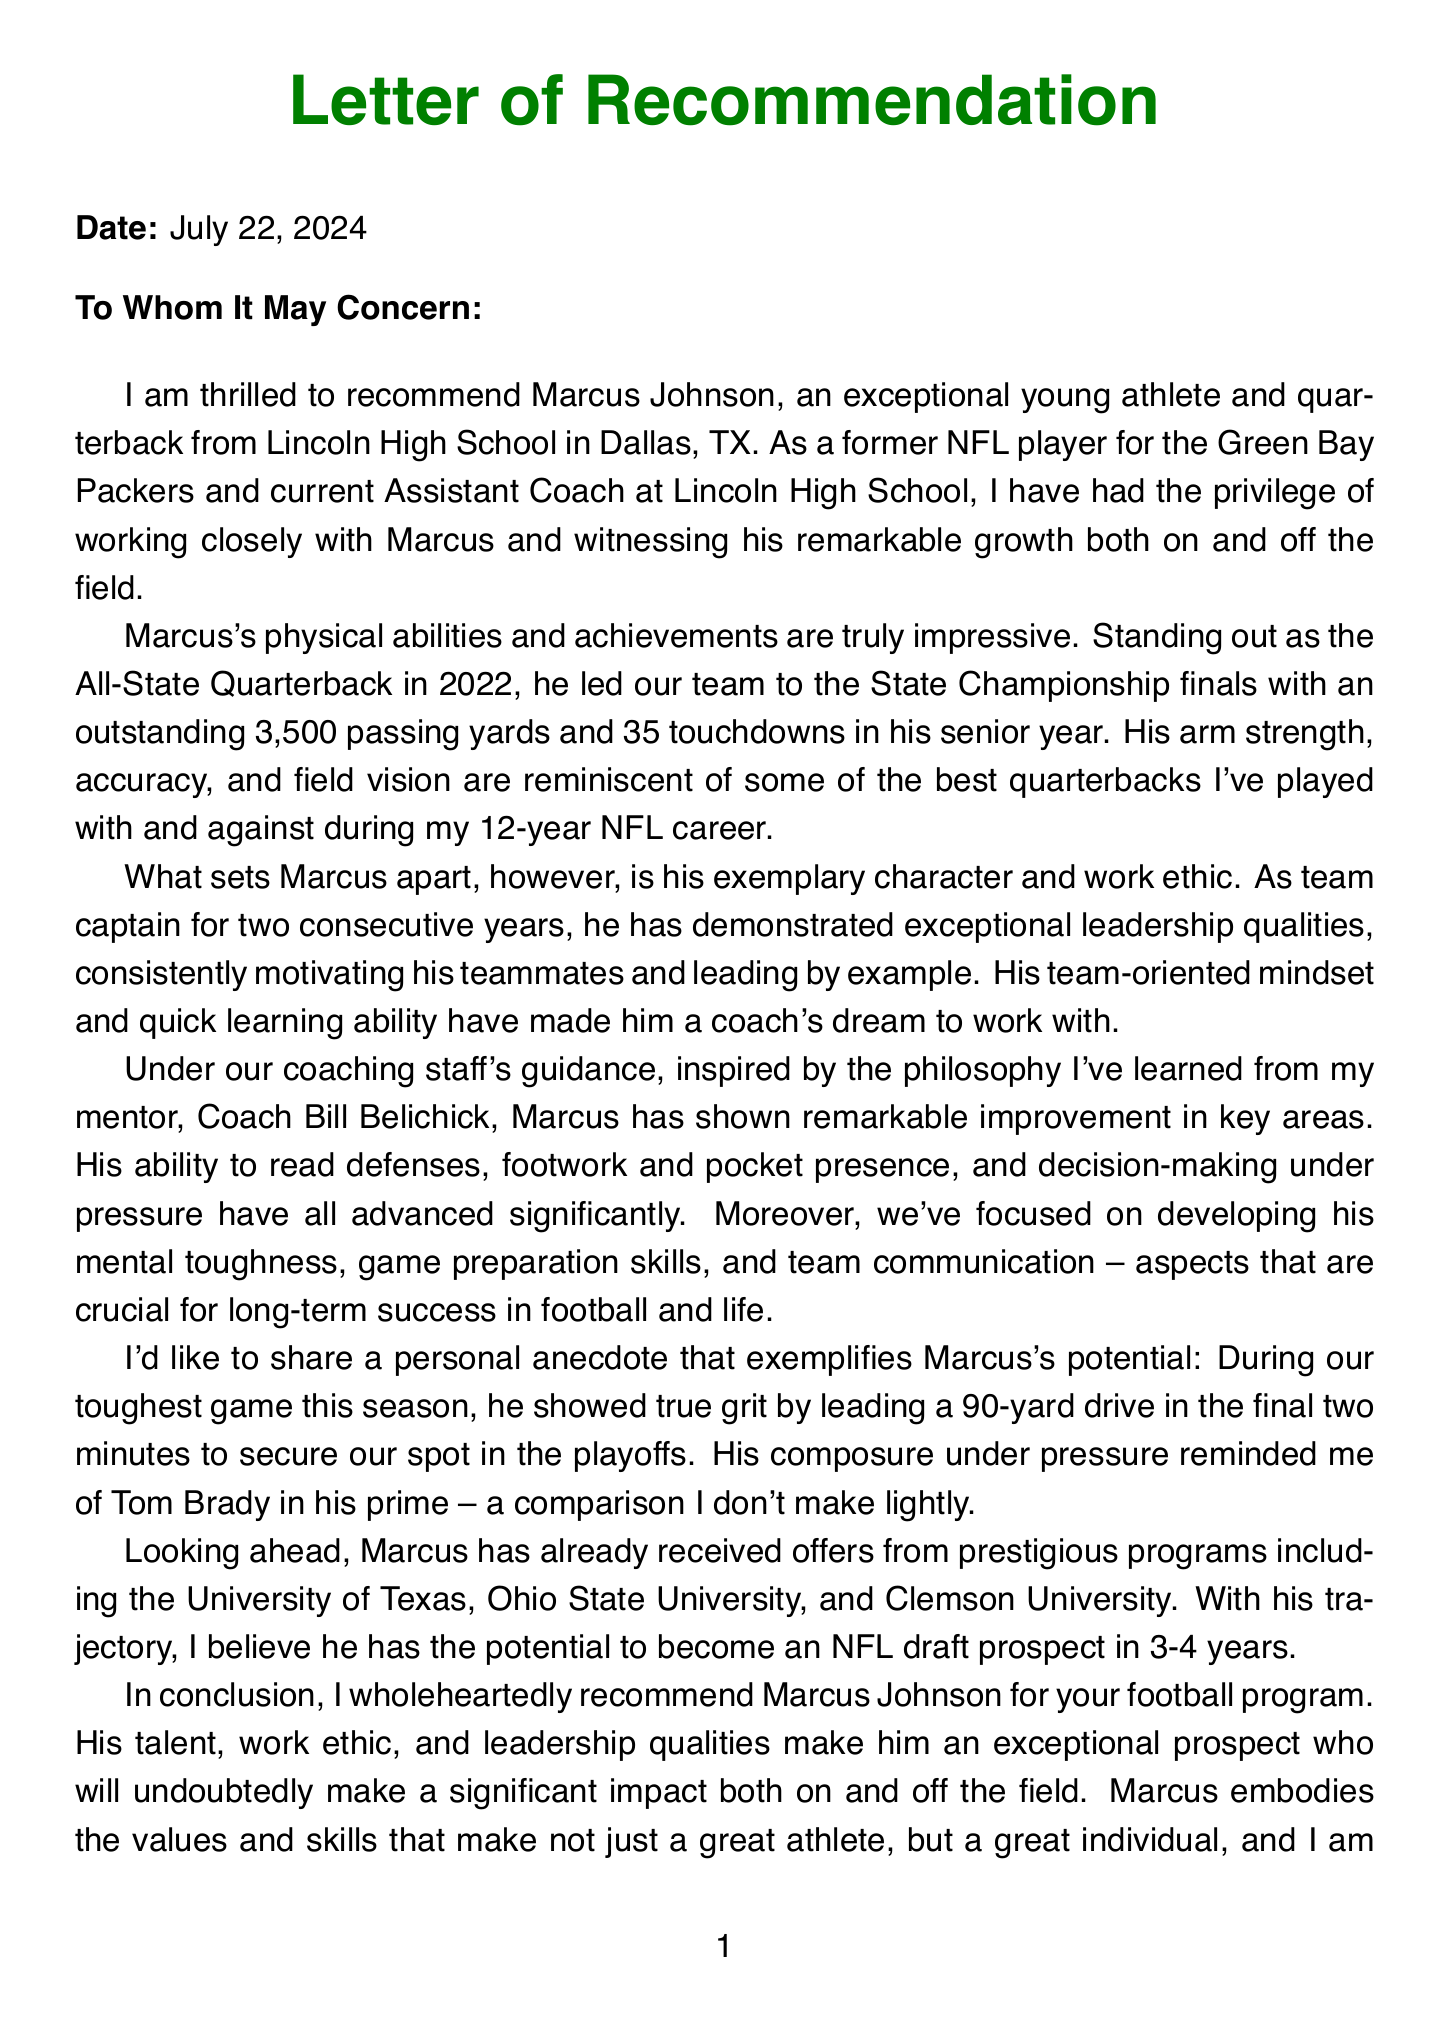What is the name of the athlete? The athlete's name is mentioned in the introduction of the document, which clearly states "Marcus Johnson."
Answer: Marcus Johnson What position does Marcus Johnson play? The specific position of the athlete is outlined in the athlete details section as being a quarterback.
Answer: Quarterback What notable achievement did Marcus receive in 2022? The document highlights that Marcus was recognized as an All-State Quarterback in the year 2022.
Answer: All-State Quarterback 2022 Which schools have offered Marcus scholarships? The document lists three prestigious institutions that have extended offers to Marcus: University of Texas, Ohio State University, and Clemson University.
Answer: University of Texas, Ohio State University, Clemson University How many touchdowns did Marcus throw in his senior year? The body paragraph detailing Marcus's achievements states that he had an impressive 35 touchdowns during his senior year.
Answer: 35 touchdowns Who is the mentor coach mentioned in the letter? The letter identifies Bill Belichick as the mentor coach who has influenced the author's coaching philosophy and methods.
Answer: Bill Belichick What is the author's current role? The author describes their current position as Assistant Coach at Lincoln High School in the letter.
Answer: Assistant Coach, Lincoln High School What personal quality is highlighted through the anecdote about Marcus? The author emphasizes Marcus's composure and grit during a challenging game situation as indicative of his character.
Answer: Composure under pressure How long did the author play in the NFL? The letter notes that the author had a total of 12 years of experience playing in the NFL.
Answer: 12 years 